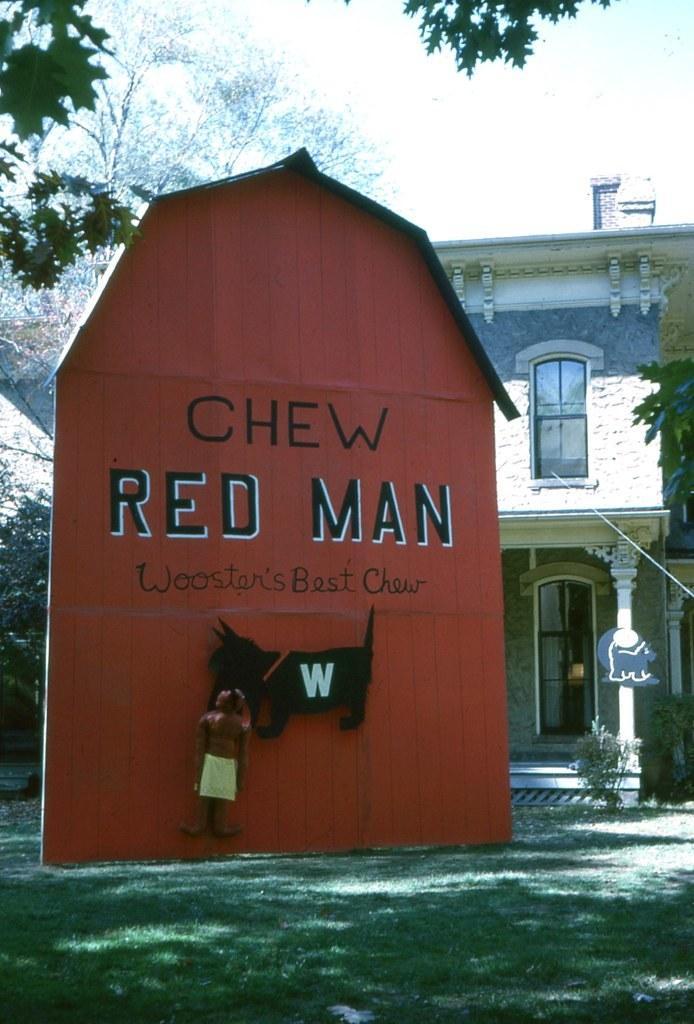How would you summarize this image in a sentence or two? In this image we can see boards, building, pillar, plants, trees and sky. In this image land is covered with grass. We can see images and something is written on the red board. 